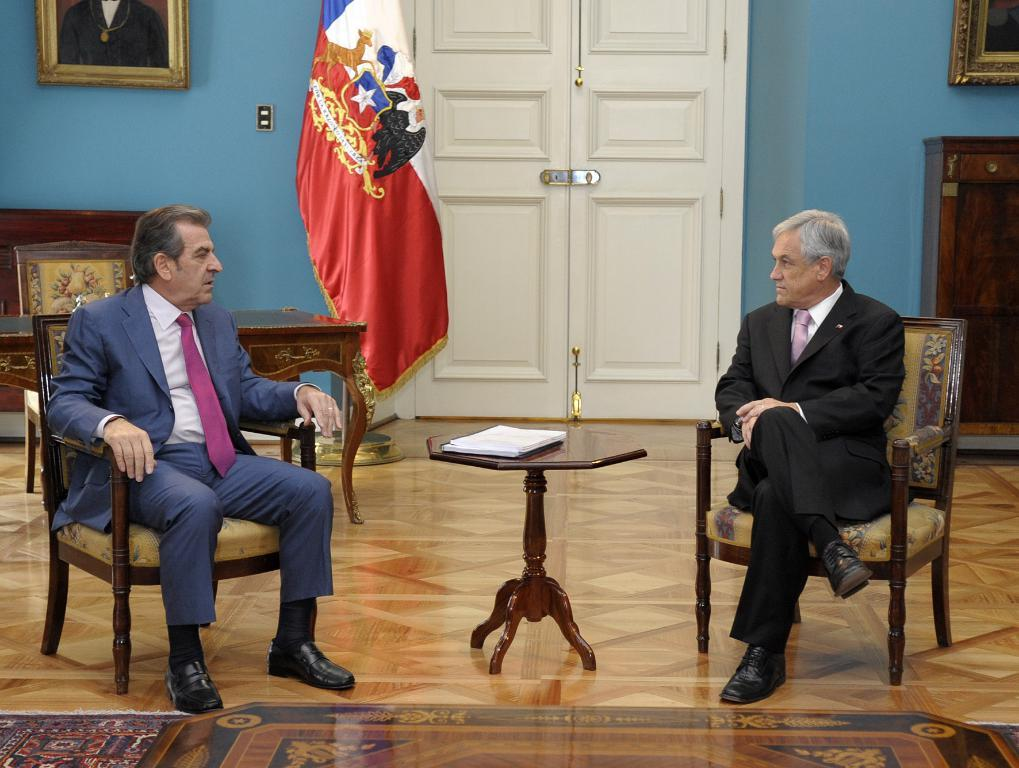How many men are sitting in the image? There are two men sitting on chairs in the image. What is present on the table in the image? There are books on the table in the image. What can be seen in the background of the image? There is a door, a flag, a wall, two photo frames, cupboards, and another table in the background of the image. What language are the babies speaking in the image? There are no babies present in the image, so it is not possible to determine the language they might be speaking. 